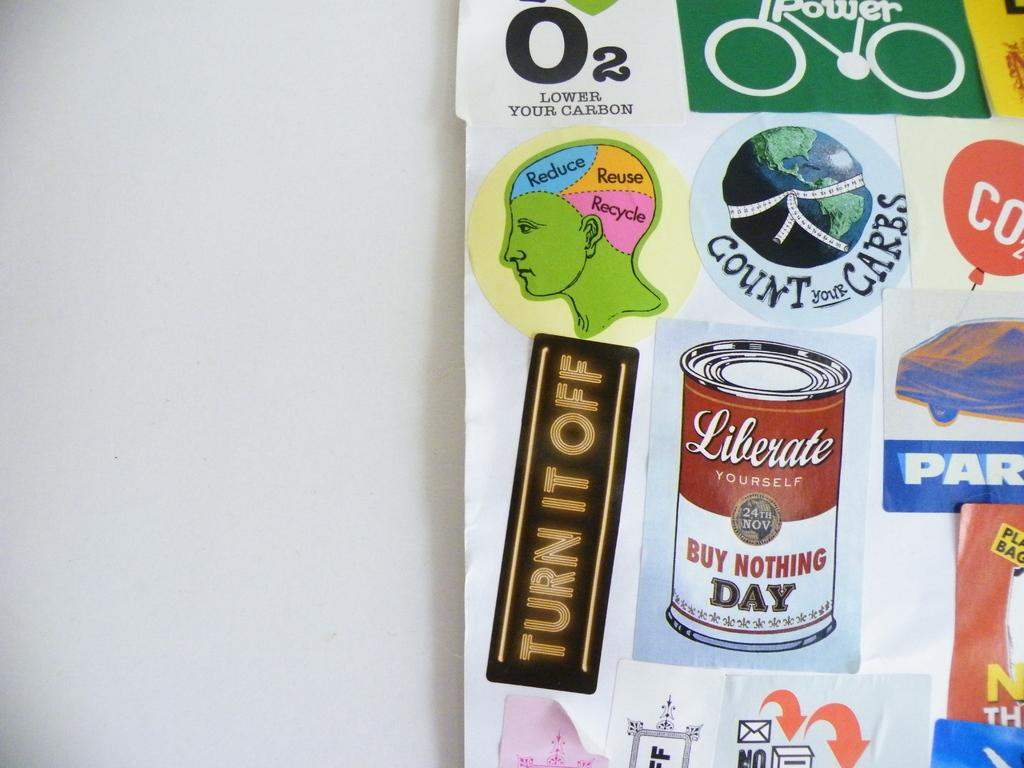What is hanging on the wall in the image? There is a chart present on the wall. What can be seen on the chart? There are multiple images on the chart. Where is the seat located in the image? There is no seat present in the image. What type of meeting is taking place in the image? There is no meeting depicted in the image. 